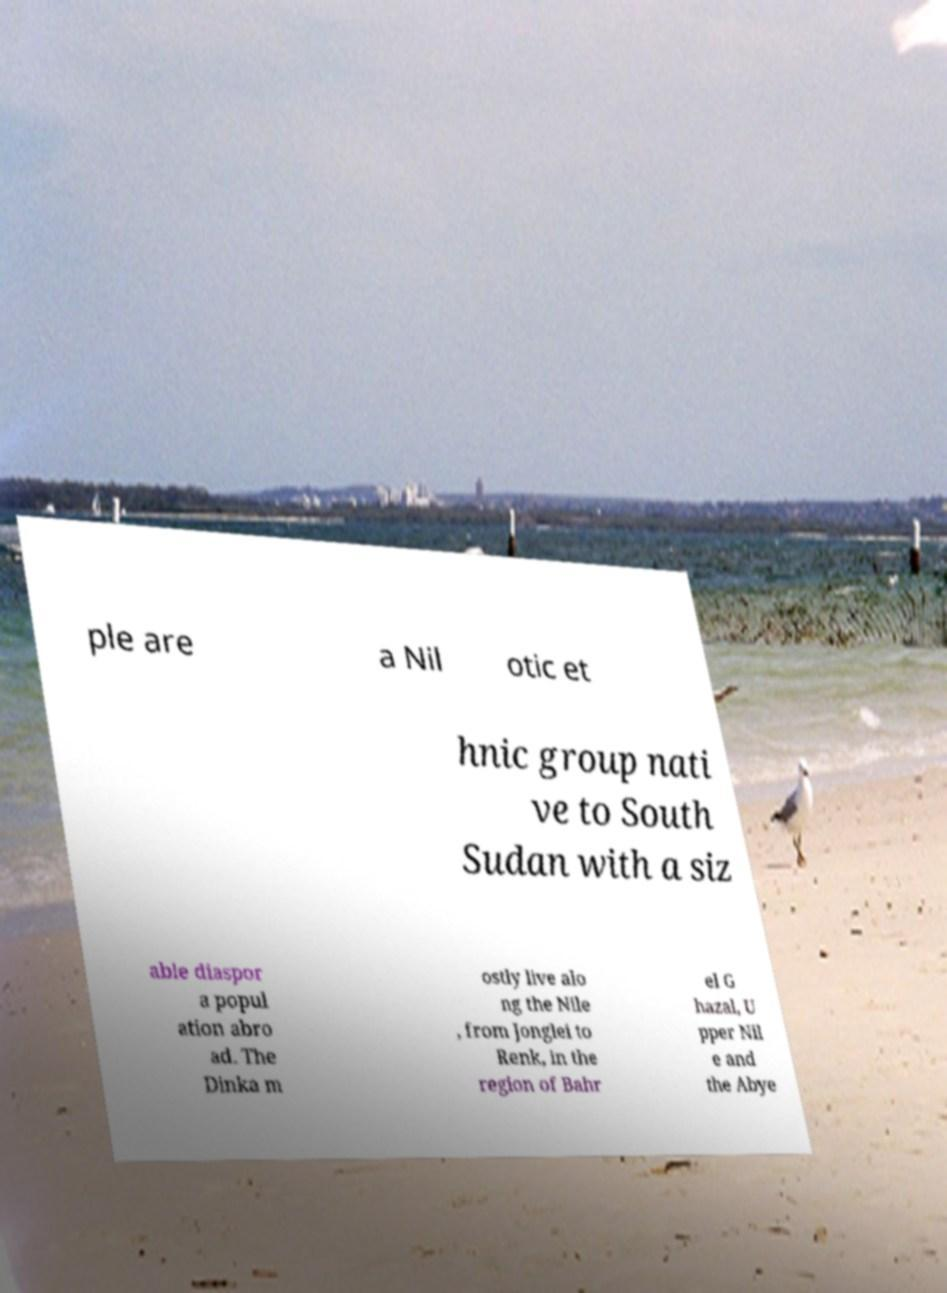Please read and relay the text visible in this image. What does it say? ple are a Nil otic et hnic group nati ve to South Sudan with a siz able diaspor a popul ation abro ad. The Dinka m ostly live alo ng the Nile , from Jonglei to Renk, in the region of Bahr el G hazal, U pper Nil e and the Abye 